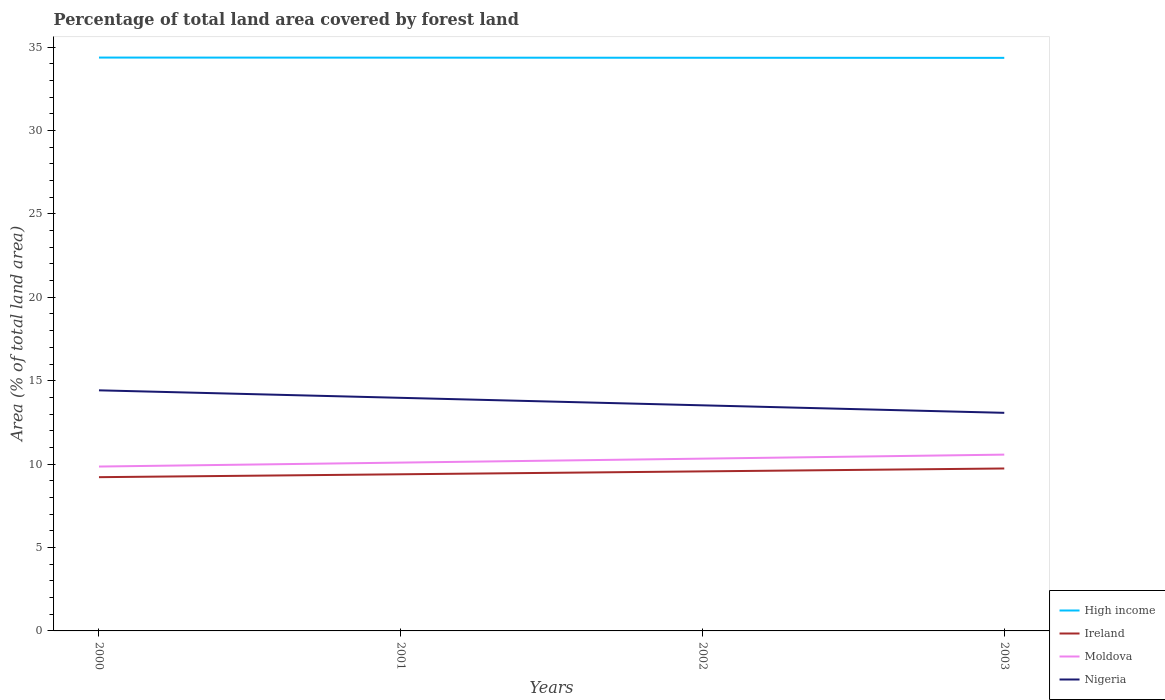How many different coloured lines are there?
Provide a succinct answer. 4. Is the number of lines equal to the number of legend labels?
Offer a terse response. Yes. Across all years, what is the maximum percentage of forest land in Nigeria?
Keep it short and to the point. 13.07. What is the total percentage of forest land in Moldova in the graph?
Keep it short and to the point. -0.24. What is the difference between the highest and the second highest percentage of forest land in High income?
Keep it short and to the point. 0.02. How many years are there in the graph?
Your answer should be compact. 4. What is the difference between two consecutive major ticks on the Y-axis?
Provide a succinct answer. 5. Are the values on the major ticks of Y-axis written in scientific E-notation?
Provide a short and direct response. No. Does the graph contain any zero values?
Offer a terse response. No. Does the graph contain grids?
Your answer should be compact. No. Where does the legend appear in the graph?
Your response must be concise. Bottom right. How are the legend labels stacked?
Offer a very short reply. Vertical. What is the title of the graph?
Ensure brevity in your answer.  Percentage of total land area covered by forest land. What is the label or title of the Y-axis?
Your answer should be very brief. Area (% of total land area). What is the Area (% of total land area) of High income in 2000?
Offer a very short reply. 34.37. What is the Area (% of total land area) in Ireland in 2000?
Offer a very short reply. 9.22. What is the Area (% of total land area) of Moldova in 2000?
Provide a short and direct response. 9.85. What is the Area (% of total land area) in Nigeria in 2000?
Offer a terse response. 14.42. What is the Area (% of total land area) of High income in 2001?
Keep it short and to the point. 34.37. What is the Area (% of total land area) in Ireland in 2001?
Provide a succinct answer. 9.39. What is the Area (% of total land area) in Moldova in 2001?
Keep it short and to the point. 10.09. What is the Area (% of total land area) in Nigeria in 2001?
Provide a succinct answer. 13.97. What is the Area (% of total land area) of High income in 2002?
Your answer should be compact. 34.36. What is the Area (% of total land area) in Ireland in 2002?
Your answer should be very brief. 9.56. What is the Area (% of total land area) of Moldova in 2002?
Keep it short and to the point. 10.33. What is the Area (% of total land area) in Nigeria in 2002?
Keep it short and to the point. 13.52. What is the Area (% of total land area) of High income in 2003?
Your response must be concise. 34.35. What is the Area (% of total land area) in Ireland in 2003?
Provide a succinct answer. 9.74. What is the Area (% of total land area) of Moldova in 2003?
Your answer should be very brief. 10.57. What is the Area (% of total land area) of Nigeria in 2003?
Your response must be concise. 13.07. Across all years, what is the maximum Area (% of total land area) in High income?
Offer a very short reply. 34.37. Across all years, what is the maximum Area (% of total land area) of Ireland?
Provide a short and direct response. 9.74. Across all years, what is the maximum Area (% of total land area) in Moldova?
Keep it short and to the point. 10.57. Across all years, what is the maximum Area (% of total land area) in Nigeria?
Give a very brief answer. 14.42. Across all years, what is the minimum Area (% of total land area) in High income?
Make the answer very short. 34.35. Across all years, what is the minimum Area (% of total land area) in Ireland?
Give a very brief answer. 9.22. Across all years, what is the minimum Area (% of total land area) in Moldova?
Your response must be concise. 9.85. Across all years, what is the minimum Area (% of total land area) in Nigeria?
Make the answer very short. 13.07. What is the total Area (% of total land area) in High income in the graph?
Provide a succinct answer. 137.46. What is the total Area (% of total land area) in Ireland in the graph?
Your answer should be compact. 37.91. What is the total Area (% of total land area) of Moldova in the graph?
Provide a succinct answer. 40.84. What is the total Area (% of total land area) of Nigeria in the graph?
Provide a succinct answer. 55. What is the difference between the Area (% of total land area) in High income in 2000 and that in 2001?
Keep it short and to the point. 0.01. What is the difference between the Area (% of total land area) in Ireland in 2000 and that in 2001?
Your answer should be compact. -0.17. What is the difference between the Area (% of total land area) in Moldova in 2000 and that in 2001?
Your answer should be very brief. -0.24. What is the difference between the Area (% of total land area) of Nigeria in 2000 and that in 2001?
Offer a terse response. 0.45. What is the difference between the Area (% of total land area) of High income in 2000 and that in 2002?
Give a very brief answer. 0.01. What is the difference between the Area (% of total land area) in Ireland in 2000 and that in 2002?
Your response must be concise. -0.35. What is the difference between the Area (% of total land area) in Moldova in 2000 and that in 2002?
Keep it short and to the point. -0.47. What is the difference between the Area (% of total land area) in Nigeria in 2000 and that in 2002?
Offer a very short reply. 0.9. What is the difference between the Area (% of total land area) of High income in 2000 and that in 2003?
Give a very brief answer. 0.02. What is the difference between the Area (% of total land area) of Ireland in 2000 and that in 2003?
Your answer should be compact. -0.52. What is the difference between the Area (% of total land area) of Moldova in 2000 and that in 2003?
Provide a short and direct response. -0.71. What is the difference between the Area (% of total land area) of Nigeria in 2000 and that in 2003?
Your answer should be very brief. 1.35. What is the difference between the Area (% of total land area) of High income in 2001 and that in 2002?
Keep it short and to the point. 0.01. What is the difference between the Area (% of total land area) of Ireland in 2001 and that in 2002?
Make the answer very short. -0.17. What is the difference between the Area (% of total land area) in Moldova in 2001 and that in 2002?
Ensure brevity in your answer.  -0.24. What is the difference between the Area (% of total land area) of Nigeria in 2001 and that in 2002?
Offer a terse response. 0.45. What is the difference between the Area (% of total land area) of High income in 2001 and that in 2003?
Your answer should be compact. 0.01. What is the difference between the Area (% of total land area) in Ireland in 2001 and that in 2003?
Your answer should be very brief. -0.35. What is the difference between the Area (% of total land area) in Moldova in 2001 and that in 2003?
Provide a short and direct response. -0.48. What is the difference between the Area (% of total land area) of Nigeria in 2001 and that in 2003?
Your answer should be very brief. 0.9. What is the difference between the Area (% of total land area) in High income in 2002 and that in 2003?
Offer a terse response. 0.01. What is the difference between the Area (% of total land area) of Ireland in 2002 and that in 2003?
Provide a succinct answer. -0.17. What is the difference between the Area (% of total land area) of Moldova in 2002 and that in 2003?
Keep it short and to the point. -0.24. What is the difference between the Area (% of total land area) in Nigeria in 2002 and that in 2003?
Provide a succinct answer. 0.45. What is the difference between the Area (% of total land area) in High income in 2000 and the Area (% of total land area) in Ireland in 2001?
Your answer should be compact. 24.98. What is the difference between the Area (% of total land area) of High income in 2000 and the Area (% of total land area) of Moldova in 2001?
Your answer should be very brief. 24.28. What is the difference between the Area (% of total land area) of High income in 2000 and the Area (% of total land area) of Nigeria in 2001?
Ensure brevity in your answer.  20.4. What is the difference between the Area (% of total land area) of Ireland in 2000 and the Area (% of total land area) of Moldova in 2001?
Your response must be concise. -0.87. What is the difference between the Area (% of total land area) in Ireland in 2000 and the Area (% of total land area) in Nigeria in 2001?
Offer a terse response. -4.76. What is the difference between the Area (% of total land area) of Moldova in 2000 and the Area (% of total land area) of Nigeria in 2001?
Give a very brief answer. -4.12. What is the difference between the Area (% of total land area) in High income in 2000 and the Area (% of total land area) in Ireland in 2002?
Make the answer very short. 24.81. What is the difference between the Area (% of total land area) in High income in 2000 and the Area (% of total land area) in Moldova in 2002?
Offer a very short reply. 24.04. What is the difference between the Area (% of total land area) in High income in 2000 and the Area (% of total land area) in Nigeria in 2002?
Your answer should be compact. 20.85. What is the difference between the Area (% of total land area) of Ireland in 2000 and the Area (% of total land area) of Moldova in 2002?
Your response must be concise. -1.11. What is the difference between the Area (% of total land area) in Ireland in 2000 and the Area (% of total land area) in Nigeria in 2002?
Offer a very short reply. -4.31. What is the difference between the Area (% of total land area) of Moldova in 2000 and the Area (% of total land area) of Nigeria in 2002?
Offer a very short reply. -3.67. What is the difference between the Area (% of total land area) in High income in 2000 and the Area (% of total land area) in Ireland in 2003?
Offer a terse response. 24.63. What is the difference between the Area (% of total land area) of High income in 2000 and the Area (% of total land area) of Moldova in 2003?
Your answer should be very brief. 23.8. What is the difference between the Area (% of total land area) of High income in 2000 and the Area (% of total land area) of Nigeria in 2003?
Your response must be concise. 21.3. What is the difference between the Area (% of total land area) of Ireland in 2000 and the Area (% of total land area) of Moldova in 2003?
Give a very brief answer. -1.35. What is the difference between the Area (% of total land area) of Ireland in 2000 and the Area (% of total land area) of Nigeria in 2003?
Ensure brevity in your answer.  -3.86. What is the difference between the Area (% of total land area) in Moldova in 2000 and the Area (% of total land area) in Nigeria in 2003?
Give a very brief answer. -3.22. What is the difference between the Area (% of total land area) in High income in 2001 and the Area (% of total land area) in Ireland in 2002?
Your answer should be compact. 24.8. What is the difference between the Area (% of total land area) of High income in 2001 and the Area (% of total land area) of Moldova in 2002?
Your response must be concise. 24.04. What is the difference between the Area (% of total land area) in High income in 2001 and the Area (% of total land area) in Nigeria in 2002?
Offer a very short reply. 20.84. What is the difference between the Area (% of total land area) in Ireland in 2001 and the Area (% of total land area) in Moldova in 2002?
Your answer should be very brief. -0.94. What is the difference between the Area (% of total land area) of Ireland in 2001 and the Area (% of total land area) of Nigeria in 2002?
Make the answer very short. -4.13. What is the difference between the Area (% of total land area) in Moldova in 2001 and the Area (% of total land area) in Nigeria in 2002?
Provide a succinct answer. -3.43. What is the difference between the Area (% of total land area) in High income in 2001 and the Area (% of total land area) in Ireland in 2003?
Your answer should be compact. 24.63. What is the difference between the Area (% of total land area) of High income in 2001 and the Area (% of total land area) of Moldova in 2003?
Make the answer very short. 23.8. What is the difference between the Area (% of total land area) in High income in 2001 and the Area (% of total land area) in Nigeria in 2003?
Offer a very short reply. 21.29. What is the difference between the Area (% of total land area) of Ireland in 2001 and the Area (% of total land area) of Moldova in 2003?
Your answer should be very brief. -1.18. What is the difference between the Area (% of total land area) in Ireland in 2001 and the Area (% of total land area) in Nigeria in 2003?
Make the answer very short. -3.68. What is the difference between the Area (% of total land area) in Moldova in 2001 and the Area (% of total land area) in Nigeria in 2003?
Your answer should be very brief. -2.98. What is the difference between the Area (% of total land area) in High income in 2002 and the Area (% of total land area) in Ireland in 2003?
Your answer should be compact. 24.62. What is the difference between the Area (% of total land area) of High income in 2002 and the Area (% of total land area) of Moldova in 2003?
Your answer should be very brief. 23.79. What is the difference between the Area (% of total land area) of High income in 2002 and the Area (% of total land area) of Nigeria in 2003?
Ensure brevity in your answer.  21.29. What is the difference between the Area (% of total land area) in Ireland in 2002 and the Area (% of total land area) in Moldova in 2003?
Offer a terse response. -1. What is the difference between the Area (% of total land area) in Ireland in 2002 and the Area (% of total land area) in Nigeria in 2003?
Offer a terse response. -3.51. What is the difference between the Area (% of total land area) of Moldova in 2002 and the Area (% of total land area) of Nigeria in 2003?
Make the answer very short. -2.75. What is the average Area (% of total land area) in High income per year?
Make the answer very short. 34.36. What is the average Area (% of total land area) of Ireland per year?
Your answer should be very brief. 9.48. What is the average Area (% of total land area) in Moldova per year?
Your answer should be compact. 10.21. What is the average Area (% of total land area) in Nigeria per year?
Your response must be concise. 13.75. In the year 2000, what is the difference between the Area (% of total land area) in High income and Area (% of total land area) in Ireland?
Your response must be concise. 25.16. In the year 2000, what is the difference between the Area (% of total land area) in High income and Area (% of total land area) in Moldova?
Your answer should be compact. 24.52. In the year 2000, what is the difference between the Area (% of total land area) in High income and Area (% of total land area) in Nigeria?
Ensure brevity in your answer.  19.95. In the year 2000, what is the difference between the Area (% of total land area) in Ireland and Area (% of total land area) in Moldova?
Provide a short and direct response. -0.64. In the year 2000, what is the difference between the Area (% of total land area) of Ireland and Area (% of total land area) of Nigeria?
Your answer should be very brief. -5.21. In the year 2000, what is the difference between the Area (% of total land area) in Moldova and Area (% of total land area) in Nigeria?
Make the answer very short. -4.57. In the year 2001, what is the difference between the Area (% of total land area) in High income and Area (% of total land area) in Ireland?
Your answer should be very brief. 24.98. In the year 2001, what is the difference between the Area (% of total land area) of High income and Area (% of total land area) of Moldova?
Your response must be concise. 24.28. In the year 2001, what is the difference between the Area (% of total land area) of High income and Area (% of total land area) of Nigeria?
Provide a succinct answer. 20.39. In the year 2001, what is the difference between the Area (% of total land area) of Ireland and Area (% of total land area) of Moldova?
Provide a succinct answer. -0.7. In the year 2001, what is the difference between the Area (% of total land area) of Ireland and Area (% of total land area) of Nigeria?
Give a very brief answer. -4.58. In the year 2001, what is the difference between the Area (% of total land area) of Moldova and Area (% of total land area) of Nigeria?
Keep it short and to the point. -3.88. In the year 2002, what is the difference between the Area (% of total land area) of High income and Area (% of total land area) of Ireland?
Your answer should be compact. 24.8. In the year 2002, what is the difference between the Area (% of total land area) in High income and Area (% of total land area) in Moldova?
Your answer should be very brief. 24.03. In the year 2002, what is the difference between the Area (% of total land area) of High income and Area (% of total land area) of Nigeria?
Ensure brevity in your answer.  20.84. In the year 2002, what is the difference between the Area (% of total land area) in Ireland and Area (% of total land area) in Moldova?
Provide a short and direct response. -0.76. In the year 2002, what is the difference between the Area (% of total land area) in Ireland and Area (% of total land area) in Nigeria?
Offer a terse response. -3.96. In the year 2002, what is the difference between the Area (% of total land area) of Moldova and Area (% of total land area) of Nigeria?
Offer a terse response. -3.2. In the year 2003, what is the difference between the Area (% of total land area) in High income and Area (% of total land area) in Ireland?
Provide a succinct answer. 24.62. In the year 2003, what is the difference between the Area (% of total land area) of High income and Area (% of total land area) of Moldova?
Offer a very short reply. 23.79. In the year 2003, what is the difference between the Area (% of total land area) of High income and Area (% of total land area) of Nigeria?
Provide a short and direct response. 21.28. In the year 2003, what is the difference between the Area (% of total land area) in Ireland and Area (% of total land area) in Moldova?
Your response must be concise. -0.83. In the year 2003, what is the difference between the Area (% of total land area) in Ireland and Area (% of total land area) in Nigeria?
Make the answer very short. -3.34. In the year 2003, what is the difference between the Area (% of total land area) in Moldova and Area (% of total land area) in Nigeria?
Ensure brevity in your answer.  -2.51. What is the ratio of the Area (% of total land area) of High income in 2000 to that in 2001?
Your answer should be compact. 1. What is the ratio of the Area (% of total land area) in Ireland in 2000 to that in 2001?
Your response must be concise. 0.98. What is the ratio of the Area (% of total land area) of Moldova in 2000 to that in 2001?
Provide a short and direct response. 0.98. What is the ratio of the Area (% of total land area) of Nigeria in 2000 to that in 2001?
Ensure brevity in your answer.  1.03. What is the ratio of the Area (% of total land area) in Ireland in 2000 to that in 2002?
Provide a succinct answer. 0.96. What is the ratio of the Area (% of total land area) in Moldova in 2000 to that in 2002?
Offer a terse response. 0.95. What is the ratio of the Area (% of total land area) of Nigeria in 2000 to that in 2002?
Give a very brief answer. 1.07. What is the ratio of the Area (% of total land area) of High income in 2000 to that in 2003?
Ensure brevity in your answer.  1. What is the ratio of the Area (% of total land area) of Ireland in 2000 to that in 2003?
Offer a terse response. 0.95. What is the ratio of the Area (% of total land area) of Moldova in 2000 to that in 2003?
Offer a very short reply. 0.93. What is the ratio of the Area (% of total land area) in Nigeria in 2000 to that in 2003?
Offer a terse response. 1.1. What is the ratio of the Area (% of total land area) of Ireland in 2001 to that in 2002?
Your answer should be very brief. 0.98. What is the ratio of the Area (% of total land area) of High income in 2001 to that in 2003?
Provide a succinct answer. 1. What is the ratio of the Area (% of total land area) in Moldova in 2001 to that in 2003?
Provide a short and direct response. 0.95. What is the ratio of the Area (% of total land area) of Nigeria in 2001 to that in 2003?
Your answer should be very brief. 1.07. What is the ratio of the Area (% of total land area) of Ireland in 2002 to that in 2003?
Keep it short and to the point. 0.98. What is the ratio of the Area (% of total land area) in Moldova in 2002 to that in 2003?
Give a very brief answer. 0.98. What is the ratio of the Area (% of total land area) in Nigeria in 2002 to that in 2003?
Make the answer very short. 1.03. What is the difference between the highest and the second highest Area (% of total land area) of High income?
Your response must be concise. 0.01. What is the difference between the highest and the second highest Area (% of total land area) in Ireland?
Your answer should be compact. 0.17. What is the difference between the highest and the second highest Area (% of total land area) in Moldova?
Provide a succinct answer. 0.24. What is the difference between the highest and the second highest Area (% of total land area) in Nigeria?
Provide a succinct answer. 0.45. What is the difference between the highest and the lowest Area (% of total land area) of High income?
Ensure brevity in your answer.  0.02. What is the difference between the highest and the lowest Area (% of total land area) of Ireland?
Ensure brevity in your answer.  0.52. What is the difference between the highest and the lowest Area (% of total land area) of Moldova?
Keep it short and to the point. 0.71. What is the difference between the highest and the lowest Area (% of total land area) of Nigeria?
Provide a succinct answer. 1.35. 